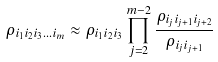Convert formula to latex. <formula><loc_0><loc_0><loc_500><loc_500>\rho _ { i _ { 1 } i _ { 2 } i _ { 3 } \dots i _ { m } } \approx \rho _ { i _ { 1 } i _ { 2 } i _ { 3 } } \prod _ { j = 2 } ^ { m - 2 } \frac { \rho _ { i _ { j } i _ { j + 1 } i _ { j + 2 } } } { \rho _ { i _ { j } i _ { j + 1 } } }</formula> 